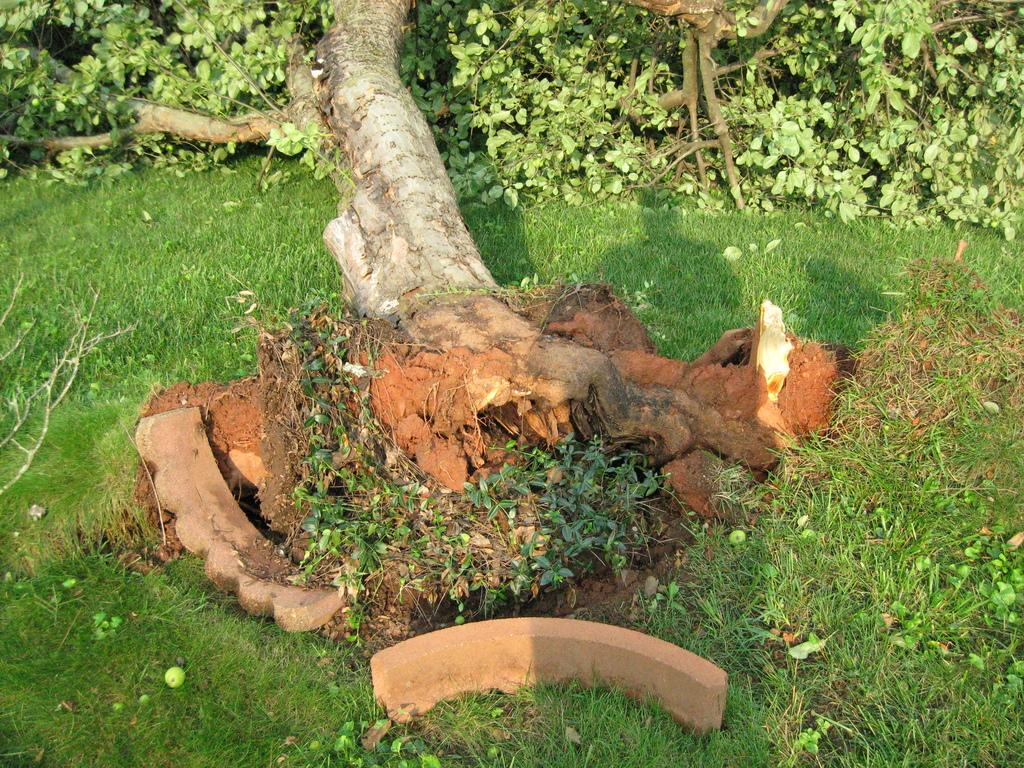What type of plant can be seen in the image? There is a tree in the image. What is the tree standing on? The tree is on grassy land. What type of structure is visible at the bottom of the image? There is a cement structure at the bottom of the image. What type of arm is visible on the tree in the image? There is no arm visible on the tree in the image; it is a tree with branches and leaves. 